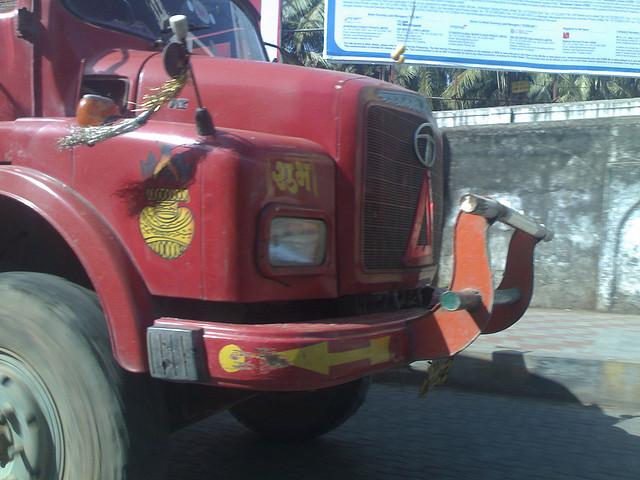What type of road is this truck on?
Be succinct. Brick. Is the arrow pointing right?
Concise answer only. No. Is there a flag on the truck?
Answer briefly. No. 